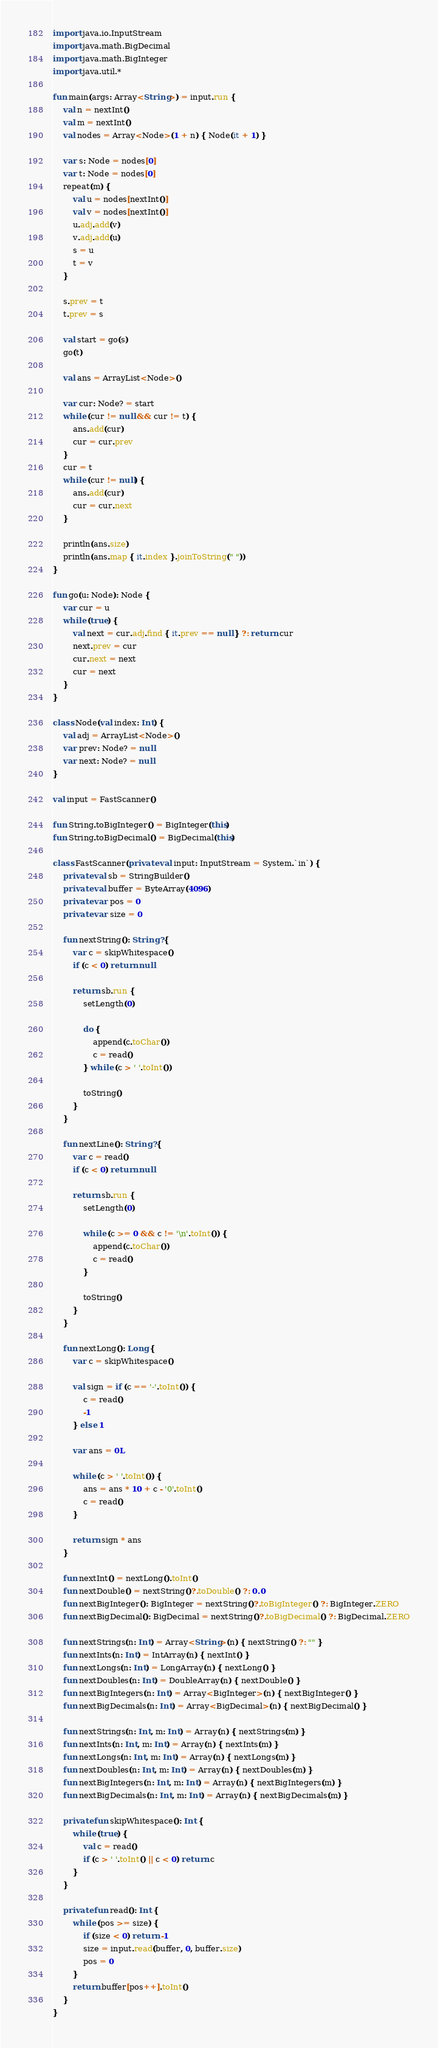<code> <loc_0><loc_0><loc_500><loc_500><_Kotlin_>import java.io.InputStream
import java.math.BigDecimal
import java.math.BigInteger
import java.util.*

fun main(args: Array<String>) = input.run {
    val n = nextInt()
    val m = nextInt()
    val nodes = Array<Node>(1 + n) { Node(it + 1) }

    var s: Node = nodes[0]
    var t: Node = nodes[0]
    repeat(m) {
        val u = nodes[nextInt()]
        val v = nodes[nextInt()]
        u.adj.add(v)
        v.adj.add(u)
        s = u
        t = v
    }

    s.prev = t
    t.prev = s

    val start = go(s)
    go(t)

    val ans = ArrayList<Node>()

    var cur: Node? = start
    while (cur != null && cur != t) {
        ans.add(cur)
        cur = cur.prev
    }
    cur = t
    while (cur != null) {
        ans.add(cur)
        cur = cur.next
    }

    println(ans.size)
    println(ans.map { it.index }.joinToString(" "))
}

fun go(u: Node): Node {
    var cur = u
    while (true) {
        val next = cur.adj.find { it.prev == null } ?: return cur
        next.prev = cur
        cur.next = next
        cur = next
    }
}

class Node(val index: Int) {
    val adj = ArrayList<Node>()
    var prev: Node? = null
    var next: Node? = null
}

val input = FastScanner()

fun String.toBigInteger() = BigInteger(this)
fun String.toBigDecimal() = BigDecimal(this)

class FastScanner(private val input: InputStream = System.`in`) {
    private val sb = StringBuilder()
    private val buffer = ByteArray(4096)
    private var pos = 0
    private var size = 0

    fun nextString(): String? {
        var c = skipWhitespace()
        if (c < 0) return null

        return sb.run {
            setLength(0)

            do {
                append(c.toChar())
                c = read()
            } while (c > ' '.toInt())

            toString()
        }
    }

    fun nextLine(): String? {
        var c = read()
        if (c < 0) return null

        return sb.run {
            setLength(0)

            while (c >= 0 && c != '\n'.toInt()) {
                append(c.toChar())
                c = read()
            }

            toString()
        }
    }

    fun nextLong(): Long {
        var c = skipWhitespace()

        val sign = if (c == '-'.toInt()) {
            c = read()
            -1
        } else 1

        var ans = 0L

        while (c > ' '.toInt()) {
            ans = ans * 10 + c - '0'.toInt()
            c = read()
        }

        return sign * ans
    }

    fun nextInt() = nextLong().toInt()
    fun nextDouble() = nextString()?.toDouble() ?: 0.0
    fun nextBigInteger(): BigInteger = nextString()?.toBigInteger() ?: BigInteger.ZERO
    fun nextBigDecimal(): BigDecimal = nextString()?.toBigDecimal() ?: BigDecimal.ZERO

    fun nextStrings(n: Int) = Array<String>(n) { nextString() ?: "" }
    fun nextInts(n: Int) = IntArray(n) { nextInt() }
    fun nextLongs(n: Int) = LongArray(n) { nextLong() }
    fun nextDoubles(n: Int) = DoubleArray(n) { nextDouble() }
    fun nextBigIntegers(n: Int) = Array<BigInteger>(n) { nextBigInteger() }
    fun nextBigDecimals(n: Int) = Array<BigDecimal>(n) { nextBigDecimal() }

    fun nextStrings(n: Int, m: Int) = Array(n) { nextStrings(m) }
    fun nextInts(n: Int, m: Int) = Array(n) { nextInts(m) }
    fun nextLongs(n: Int, m: Int) = Array(n) { nextLongs(m) }
    fun nextDoubles(n: Int, m: Int) = Array(n) { nextDoubles(m) }
    fun nextBigIntegers(n: Int, m: Int) = Array(n) { nextBigIntegers(m) }
    fun nextBigDecimals(n: Int, m: Int) = Array(n) { nextBigDecimals(m) }

    private fun skipWhitespace(): Int {
        while (true) {
            val c = read()
            if (c > ' '.toInt() || c < 0) return c
        }
    }

    private fun read(): Int {
        while (pos >= size) {
            if (size < 0) return -1
            size = input.read(buffer, 0, buffer.size)
            pos = 0
        }
        return buffer[pos++].toInt()
    }
}
</code> 